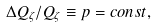Convert formula to latex. <formula><loc_0><loc_0><loc_500><loc_500>\Delta Q _ { \zeta } / Q _ { \zeta } \equiv p = c o n s t ,</formula> 